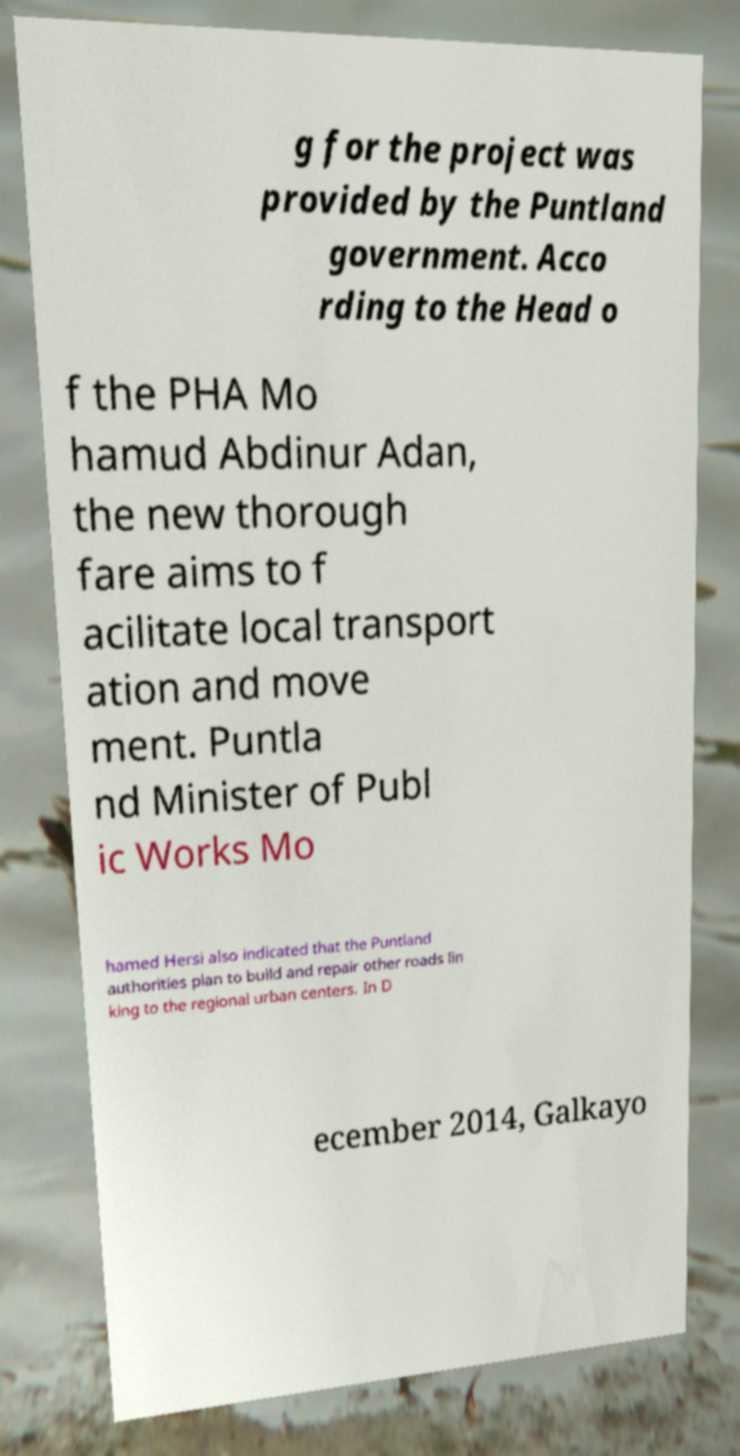Can you read and provide the text displayed in the image?This photo seems to have some interesting text. Can you extract and type it out for me? g for the project was provided by the Puntland government. Acco rding to the Head o f the PHA Mo hamud Abdinur Adan, the new thorough fare aims to f acilitate local transport ation and move ment. Puntla nd Minister of Publ ic Works Mo hamed Hersi also indicated that the Puntland authorities plan to build and repair other roads lin king to the regional urban centers. In D ecember 2014, Galkayo 